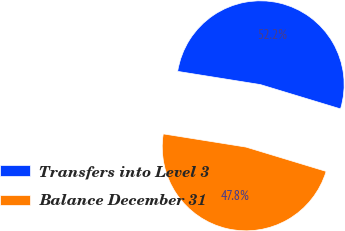<chart> <loc_0><loc_0><loc_500><loc_500><pie_chart><fcel>Transfers into Level 3<fcel>Balance December 31<nl><fcel>52.17%<fcel>47.83%<nl></chart> 